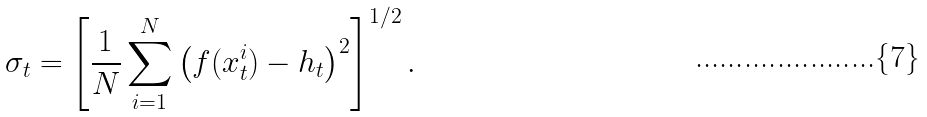<formula> <loc_0><loc_0><loc_500><loc_500>\sigma _ { t } = \left [ \frac { 1 } { N } \sum _ { i = 1 } ^ { N } \left ( f ( x ^ { i } _ { t } ) - h _ { t } \right ) ^ { 2 } \right ] ^ { 1 / 2 } .</formula> 